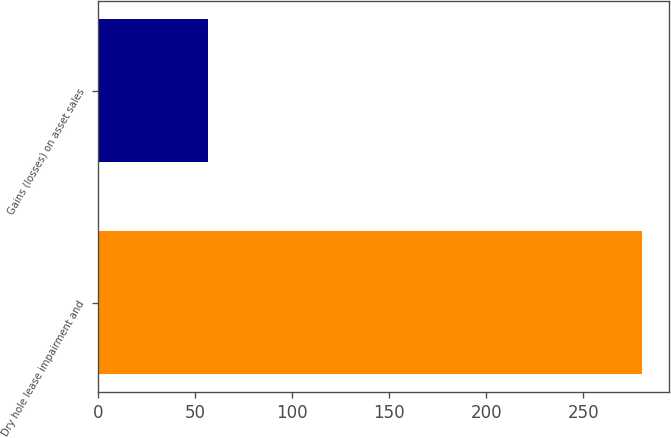Convert chart to OTSL. <chart><loc_0><loc_0><loc_500><loc_500><bar_chart><fcel>Dry hole lease impairment and<fcel>Gains (losses) on asset sales<nl><fcel>280<fcel>57<nl></chart> 